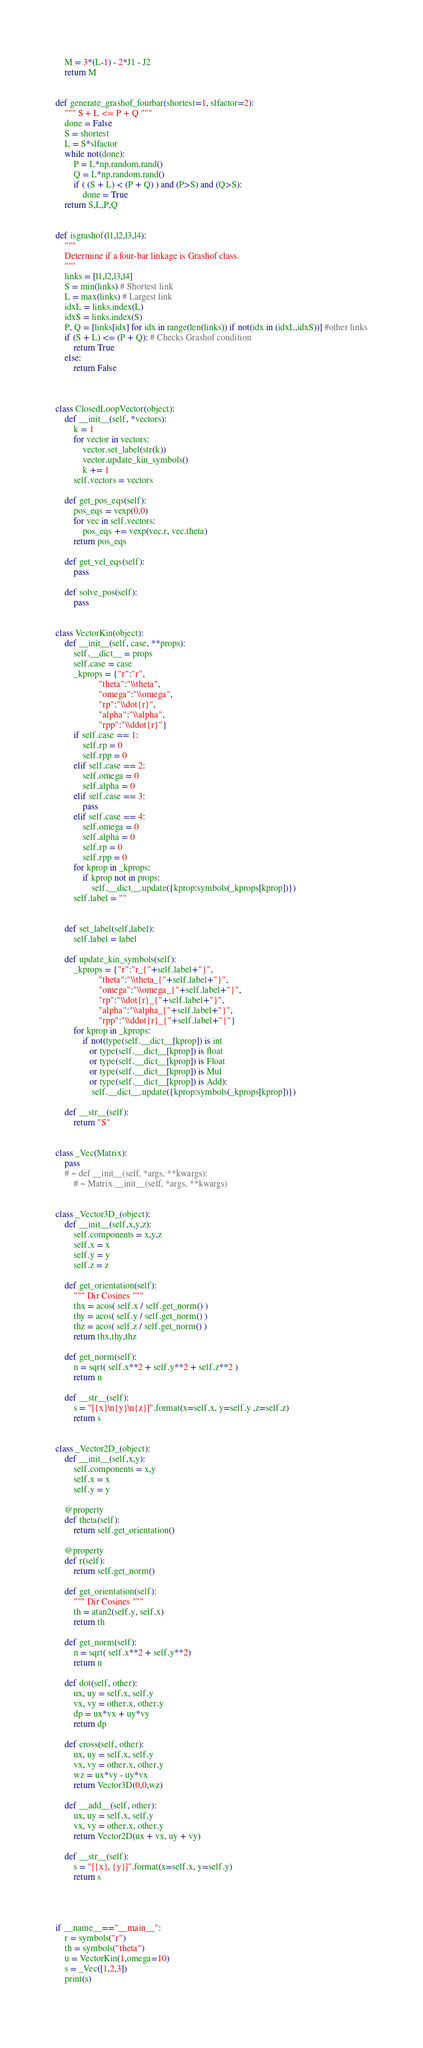Convert code to text. <code><loc_0><loc_0><loc_500><loc_500><_Python_>    M = 3*(L-1) - 2*J1 - J2
    return M
    

def generate_grashof_fourbar(shortest=1, slfactor=2):
    """ S + L <= P + Q """
    done = False
    S = shortest
    L = S*slfactor
    while not(done):
        P = L*np.random.rand()
        Q = L*np.random.rand()
        if ( (S + L) < (P + Q) ) and (P>S) and (Q>S):
            done = True
    return S,L,P,Q
    
    
def isgrashof(l1,l2,l3,l4):
    """
    Determine if a four-bar linkage is Grashof class.
    """
    links = [l1,l2,l3,l4]
    S = min(links) # Shortest link
    L = max(links) # Largest link
    idxL = links.index(L)
    idxS = links.index(S)
    P, Q = [links[idx] for idx in range(len(links)) if not(idx in (idxL,idxS))] #other links
    if (S + L) <= (P + Q): # Checks Grashof condition
        return True
    else:
        return False
        


class ClosedLoopVector(object):
    def __init__(self, *vectors):
        k = 1
        for vector in vectors:
            vector.set_label(str(k))
            vector.update_kin_symbols()
            k += 1
        self.vectors = vectors
            
    def get_pos_eqs(self):
        pos_eqs = vexp(0,0)
        for vec in self.vectors:
            pos_eqs += vexp(vec.r, vec.theta)
        return pos_eqs
    
    def get_vel_eqs(self):
        pass
            
    def solve_pos(self):
        pass
        

class VectorKin(object):
    def __init__(self, case, **props):
        self.__dict__ = props
        self.case = case
        _kprops = {"r":"r",
                   "theta":"\\theta",
                   "omega":"\\omega",
                   "rp":"\\dot{r}",
                   "alpha":"\\alpha",
                   "rpp":"\\ddot{r}"}
        if self.case == 1:
            self.rp = 0
            self.rpp = 0
        elif self.case == 2:
            self.omega = 0
            self.alpha = 0
        elif self.case == 3:
            pass
        elif self.case == 4:
            self.omega = 0
            self.alpha = 0
            self.rp = 0
            self.rpp = 0
        for kprop in _kprops:
            if kprop not in props:
                self.__dict__.update({kprop:symbols(_kprops[kprop])})
        self.label = ""
        
    
    def set_label(self,label):
        self.label = label
        
    def update_kin_symbols(self):
        _kprops = {"r":"r_{"+self.label+"}",
                   "theta":"\\theta_{"+self.label+"}",
                   "omega":"\\omega_{"+self.label+"}",
                   "rp":"\\dot{r}_{"+self.label+"}",
                   "alpha":"\\alpha_{"+self.label+"}",
                   "rpp":"\\ddot{r}_{"+self.label+"}"}
        for kprop in _kprops:
            if not(type(self.__dict__[kprop]) is int 
               or type(self.__dict__[kprop]) is float 
               or type(self.__dict__[kprop]) is Float 
               or type(self.__dict__[kprop]) is Mul
               or type(self.__dict__[kprop]) is Add):
                self.__dict__.update({kprop:symbols(_kprops[kprop])})
        
    def __str__(self):
        return "S"


class _Vec(Matrix):
    pass
    # ~ def __init__(self, *args, **kwargs):
        # ~ Matrix.__init__(self, *args, **kwargs)
    

class _Vector3D_(object):
    def __init__(self,x,y,z):
        self.components = x,y,z
        self.x = x 
        self.y = y
        self.z = z
        
    def get_orientation(self):
        """ Dir Cosines """
        thx = acos( self.x / self.get_norm() )
        thy = acos( self.y / self.get_norm() )
        thz = acos( self.z / self.get_norm() )
        return thx,thy,thz
        
    def get_norm(self):
        n = sqrt( self.x**2 + self.y**2 + self.z**2 )
        return n
        
    def __str__(self):
        s = "[{x}\n{y}\n{z}]".format(x=self.x, y=self.y ,z=self.z)
        return s


class _Vector2D_(object):
    def __init__(self,x,y):
        self.components = x,y
        self.x = x 
        self.y = y
        
    @property
    def theta(self):
        return self.get_orientation()
    
    @property
    def r(self):
        return self.get_norm()
        
    def get_orientation(self):
        """ Dir Cosines """
        th = atan2(self.y, self.x)
        return th
        
    def get_norm(self):
        n = sqrt( self.x**2 + self.y**2)
        return n
        
    def dot(self, other):
        ux, uy = self.x, self.y
        vx, vy = other.x, other.y
        dp = ux*vx + uy*vy
        return dp
        
    def cross(self, other):
        ux, uy = self.x, self.y
        vx, vy = other.x, other.y
        wz = ux*vy - uy*vx
        return Vector3D(0,0,wz)
                
    def __add__(self, other):
        ux, uy = self.x, self.y
        vx, vy = other.x, other.y
        return Vector2D(ux + vx, uy + vy)
    
    def __str__(self):
        s = "[{x}, {y}]".format(x=self.x, y=self.y)
        return s
        



if __name__=="__main__":
    r = symbols("r")
    th = symbols("theta")
    u = VectorKin(1,omega=10)
    s = _Vec([1,2,3])
    print(s)
    
</code> 